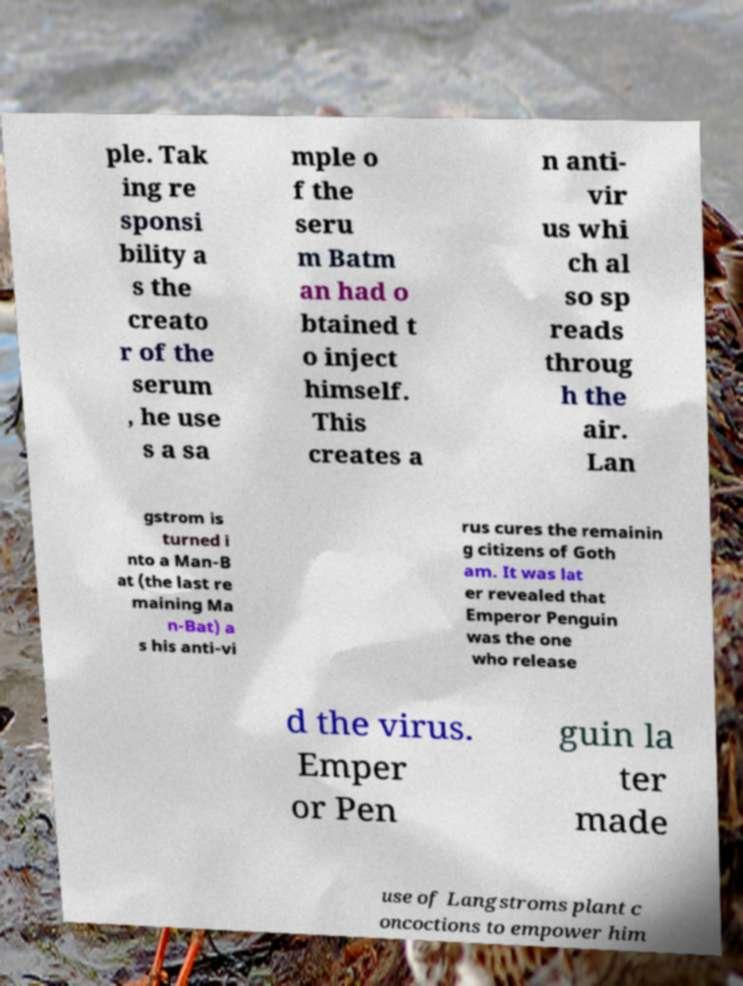Please identify and transcribe the text found in this image. ple. Tak ing re sponsi bility a s the creato r of the serum , he use s a sa mple o f the seru m Batm an had o btained t o inject himself. This creates a n anti- vir us whi ch al so sp reads throug h the air. Lan gstrom is turned i nto a Man-B at (the last re maining Ma n-Bat) a s his anti-vi rus cures the remainin g citizens of Goth am. It was lat er revealed that Emperor Penguin was the one who release d the virus. Emper or Pen guin la ter made use of Langstroms plant c oncoctions to empower him 